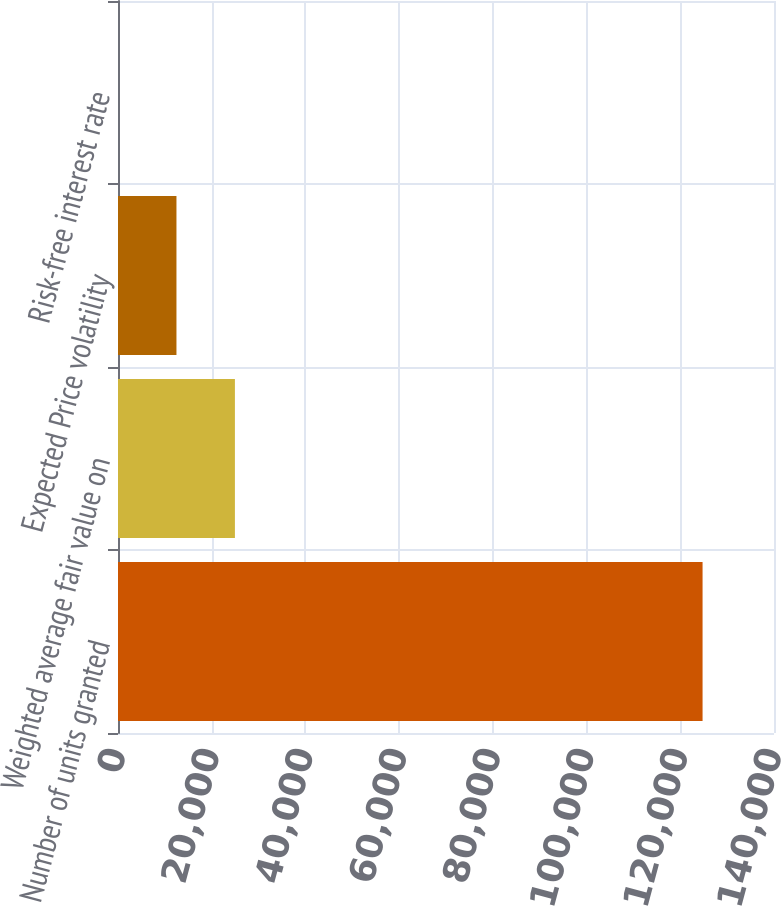Convert chart. <chart><loc_0><loc_0><loc_500><loc_500><bar_chart><fcel>Number of units granted<fcel>Weighted average fair value on<fcel>Expected Price volatility<fcel>Risk-free interest rate<nl><fcel>124755<fcel>24951.8<fcel>12476.4<fcel>0.98<nl></chart> 